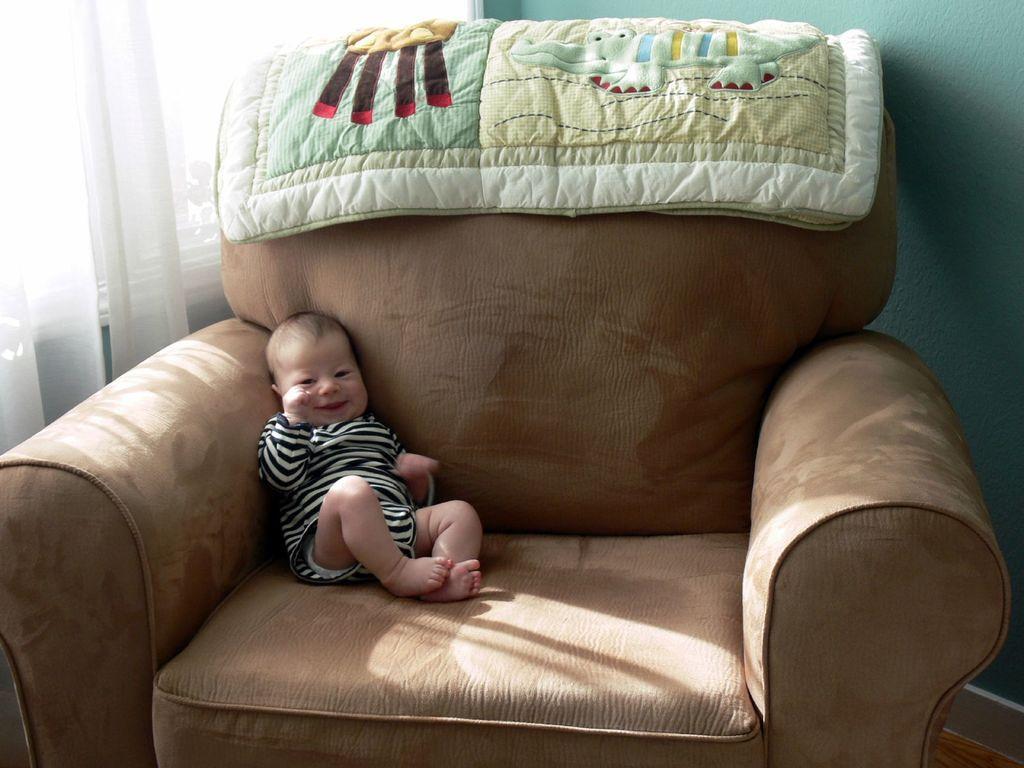Please provide a concise description of this image. In this picture there is a small baby on a sofa in the image, there is baby blanket at the top side of the image, there is curtain in the background area of the image. 